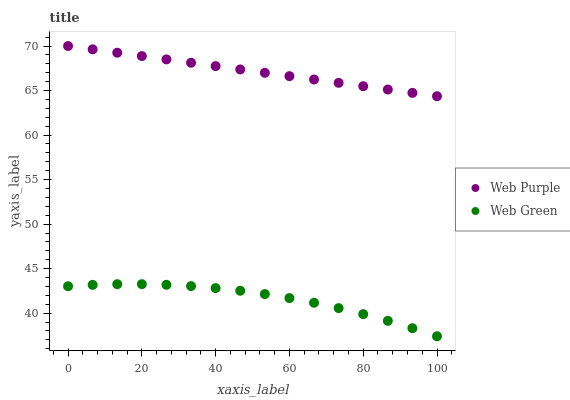Does Web Green have the minimum area under the curve?
Answer yes or no. Yes. Does Web Purple have the maximum area under the curve?
Answer yes or no. Yes. Does Web Green have the maximum area under the curve?
Answer yes or no. No. Is Web Purple the smoothest?
Answer yes or no. Yes. Is Web Green the roughest?
Answer yes or no. Yes. Is Web Green the smoothest?
Answer yes or no. No. Does Web Green have the lowest value?
Answer yes or no. Yes. Does Web Purple have the highest value?
Answer yes or no. Yes. Does Web Green have the highest value?
Answer yes or no. No. Is Web Green less than Web Purple?
Answer yes or no. Yes. Is Web Purple greater than Web Green?
Answer yes or no. Yes. Does Web Green intersect Web Purple?
Answer yes or no. No. 